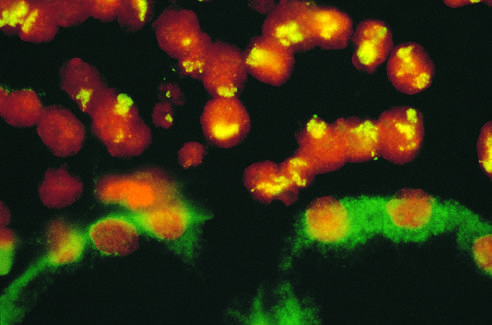what corresponds to amplified n-myc in the form of homogeneously staining regions?
Answer the question using a single word or phrase. The neuroblastoma cells on the upper half of the photo with large areas of staining (yellow-green) 